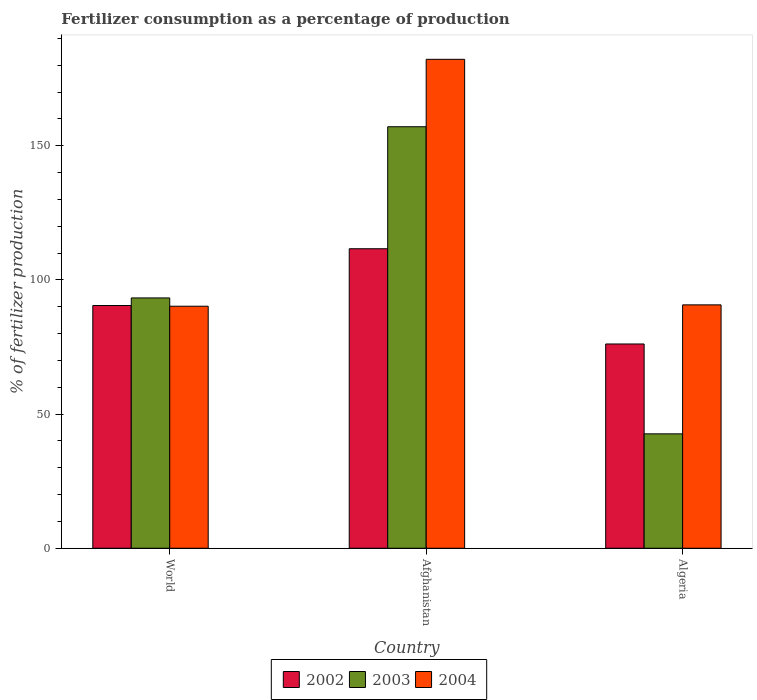Are the number of bars per tick equal to the number of legend labels?
Make the answer very short. Yes. Are the number of bars on each tick of the X-axis equal?
Offer a terse response. Yes. How many bars are there on the 3rd tick from the left?
Offer a terse response. 3. What is the label of the 3rd group of bars from the left?
Offer a terse response. Algeria. What is the percentage of fertilizers consumed in 2004 in World?
Make the answer very short. 90.18. Across all countries, what is the maximum percentage of fertilizers consumed in 2004?
Ensure brevity in your answer.  182.19. Across all countries, what is the minimum percentage of fertilizers consumed in 2003?
Your answer should be compact. 42.63. In which country was the percentage of fertilizers consumed in 2002 maximum?
Offer a very short reply. Afghanistan. What is the total percentage of fertilizers consumed in 2004 in the graph?
Make the answer very short. 363.06. What is the difference between the percentage of fertilizers consumed in 2004 in Afghanistan and that in Algeria?
Make the answer very short. 91.5. What is the difference between the percentage of fertilizers consumed in 2003 in Algeria and the percentage of fertilizers consumed in 2004 in World?
Provide a short and direct response. -47.55. What is the average percentage of fertilizers consumed in 2004 per country?
Provide a short and direct response. 121.02. What is the difference between the percentage of fertilizers consumed of/in 2002 and percentage of fertilizers consumed of/in 2004 in Algeria?
Your answer should be very brief. -14.58. In how many countries, is the percentage of fertilizers consumed in 2004 greater than 160 %?
Give a very brief answer. 1. What is the ratio of the percentage of fertilizers consumed in 2004 in Afghanistan to that in Algeria?
Offer a terse response. 2.01. Is the percentage of fertilizers consumed in 2004 in Algeria less than that in World?
Give a very brief answer. No. What is the difference between the highest and the second highest percentage of fertilizers consumed in 2003?
Offer a terse response. -50.65. What is the difference between the highest and the lowest percentage of fertilizers consumed in 2002?
Make the answer very short. 35.49. In how many countries, is the percentage of fertilizers consumed in 2004 greater than the average percentage of fertilizers consumed in 2004 taken over all countries?
Keep it short and to the point. 1. Is the sum of the percentage of fertilizers consumed in 2004 in Algeria and World greater than the maximum percentage of fertilizers consumed in 2003 across all countries?
Offer a terse response. Yes. What does the 1st bar from the left in Afghanistan represents?
Your response must be concise. 2002. How many bars are there?
Give a very brief answer. 9. Are all the bars in the graph horizontal?
Provide a short and direct response. No. What is the difference between two consecutive major ticks on the Y-axis?
Offer a terse response. 50. Does the graph contain any zero values?
Make the answer very short. No. Does the graph contain grids?
Ensure brevity in your answer.  No. Where does the legend appear in the graph?
Provide a short and direct response. Bottom center. How are the legend labels stacked?
Make the answer very short. Horizontal. What is the title of the graph?
Your answer should be very brief. Fertilizer consumption as a percentage of production. What is the label or title of the Y-axis?
Your answer should be compact. % of fertilizer production. What is the % of fertilizer production of 2002 in World?
Your answer should be very brief. 90.45. What is the % of fertilizer production in 2003 in World?
Give a very brief answer. 93.27. What is the % of fertilizer production in 2004 in World?
Give a very brief answer. 90.18. What is the % of fertilizer production in 2002 in Afghanistan?
Give a very brief answer. 111.6. What is the % of fertilizer production in 2003 in Afghanistan?
Make the answer very short. 157.07. What is the % of fertilizer production in 2004 in Afghanistan?
Keep it short and to the point. 182.19. What is the % of fertilizer production of 2002 in Algeria?
Provide a short and direct response. 76.11. What is the % of fertilizer production in 2003 in Algeria?
Keep it short and to the point. 42.63. What is the % of fertilizer production of 2004 in Algeria?
Keep it short and to the point. 90.69. Across all countries, what is the maximum % of fertilizer production in 2002?
Provide a succinct answer. 111.6. Across all countries, what is the maximum % of fertilizer production in 2003?
Your answer should be compact. 157.07. Across all countries, what is the maximum % of fertilizer production of 2004?
Make the answer very short. 182.19. Across all countries, what is the minimum % of fertilizer production in 2002?
Your response must be concise. 76.11. Across all countries, what is the minimum % of fertilizer production in 2003?
Give a very brief answer. 42.63. Across all countries, what is the minimum % of fertilizer production in 2004?
Offer a terse response. 90.18. What is the total % of fertilizer production in 2002 in the graph?
Provide a short and direct response. 278.17. What is the total % of fertilizer production of 2003 in the graph?
Your response must be concise. 292.97. What is the total % of fertilizer production of 2004 in the graph?
Provide a short and direct response. 363.06. What is the difference between the % of fertilizer production in 2002 in World and that in Afghanistan?
Your answer should be very brief. -21.15. What is the difference between the % of fertilizer production in 2003 in World and that in Afghanistan?
Give a very brief answer. -63.79. What is the difference between the % of fertilizer production in 2004 in World and that in Afghanistan?
Offer a terse response. -92.01. What is the difference between the % of fertilizer production of 2002 in World and that in Algeria?
Provide a short and direct response. 14.34. What is the difference between the % of fertilizer production of 2003 in World and that in Algeria?
Your answer should be compact. 50.65. What is the difference between the % of fertilizer production of 2004 in World and that in Algeria?
Provide a short and direct response. -0.51. What is the difference between the % of fertilizer production of 2002 in Afghanistan and that in Algeria?
Ensure brevity in your answer.  35.49. What is the difference between the % of fertilizer production of 2003 in Afghanistan and that in Algeria?
Ensure brevity in your answer.  114.44. What is the difference between the % of fertilizer production of 2004 in Afghanistan and that in Algeria?
Keep it short and to the point. 91.5. What is the difference between the % of fertilizer production in 2002 in World and the % of fertilizer production in 2003 in Afghanistan?
Keep it short and to the point. -66.62. What is the difference between the % of fertilizer production of 2002 in World and the % of fertilizer production of 2004 in Afghanistan?
Your answer should be very brief. -91.74. What is the difference between the % of fertilizer production of 2003 in World and the % of fertilizer production of 2004 in Afghanistan?
Your answer should be compact. -88.91. What is the difference between the % of fertilizer production of 2002 in World and the % of fertilizer production of 2003 in Algeria?
Ensure brevity in your answer.  47.82. What is the difference between the % of fertilizer production in 2002 in World and the % of fertilizer production in 2004 in Algeria?
Offer a terse response. -0.24. What is the difference between the % of fertilizer production in 2003 in World and the % of fertilizer production in 2004 in Algeria?
Make the answer very short. 2.58. What is the difference between the % of fertilizer production in 2002 in Afghanistan and the % of fertilizer production in 2003 in Algeria?
Provide a succinct answer. 68.98. What is the difference between the % of fertilizer production of 2002 in Afghanistan and the % of fertilizer production of 2004 in Algeria?
Give a very brief answer. 20.91. What is the difference between the % of fertilizer production in 2003 in Afghanistan and the % of fertilizer production in 2004 in Algeria?
Provide a short and direct response. 66.37. What is the average % of fertilizer production of 2002 per country?
Your answer should be very brief. 92.72. What is the average % of fertilizer production of 2003 per country?
Provide a short and direct response. 97.66. What is the average % of fertilizer production in 2004 per country?
Your answer should be very brief. 121.02. What is the difference between the % of fertilizer production of 2002 and % of fertilizer production of 2003 in World?
Ensure brevity in your answer.  -2.83. What is the difference between the % of fertilizer production of 2002 and % of fertilizer production of 2004 in World?
Give a very brief answer. 0.27. What is the difference between the % of fertilizer production of 2003 and % of fertilizer production of 2004 in World?
Ensure brevity in your answer.  3.09. What is the difference between the % of fertilizer production of 2002 and % of fertilizer production of 2003 in Afghanistan?
Offer a very short reply. -45.46. What is the difference between the % of fertilizer production of 2002 and % of fertilizer production of 2004 in Afghanistan?
Your answer should be very brief. -70.58. What is the difference between the % of fertilizer production in 2003 and % of fertilizer production in 2004 in Afghanistan?
Your answer should be very brief. -25.12. What is the difference between the % of fertilizer production of 2002 and % of fertilizer production of 2003 in Algeria?
Give a very brief answer. 33.49. What is the difference between the % of fertilizer production in 2002 and % of fertilizer production in 2004 in Algeria?
Ensure brevity in your answer.  -14.58. What is the difference between the % of fertilizer production in 2003 and % of fertilizer production in 2004 in Algeria?
Make the answer very short. -48.06. What is the ratio of the % of fertilizer production in 2002 in World to that in Afghanistan?
Provide a short and direct response. 0.81. What is the ratio of the % of fertilizer production of 2003 in World to that in Afghanistan?
Provide a succinct answer. 0.59. What is the ratio of the % of fertilizer production in 2004 in World to that in Afghanistan?
Ensure brevity in your answer.  0.49. What is the ratio of the % of fertilizer production of 2002 in World to that in Algeria?
Your response must be concise. 1.19. What is the ratio of the % of fertilizer production of 2003 in World to that in Algeria?
Ensure brevity in your answer.  2.19. What is the ratio of the % of fertilizer production of 2004 in World to that in Algeria?
Provide a short and direct response. 0.99. What is the ratio of the % of fertilizer production of 2002 in Afghanistan to that in Algeria?
Give a very brief answer. 1.47. What is the ratio of the % of fertilizer production of 2003 in Afghanistan to that in Algeria?
Your answer should be compact. 3.68. What is the ratio of the % of fertilizer production in 2004 in Afghanistan to that in Algeria?
Your answer should be compact. 2.01. What is the difference between the highest and the second highest % of fertilizer production of 2002?
Make the answer very short. 21.15. What is the difference between the highest and the second highest % of fertilizer production of 2003?
Offer a terse response. 63.79. What is the difference between the highest and the second highest % of fertilizer production in 2004?
Make the answer very short. 91.5. What is the difference between the highest and the lowest % of fertilizer production of 2002?
Provide a short and direct response. 35.49. What is the difference between the highest and the lowest % of fertilizer production of 2003?
Make the answer very short. 114.44. What is the difference between the highest and the lowest % of fertilizer production of 2004?
Provide a succinct answer. 92.01. 